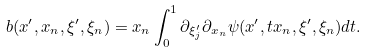Convert formula to latex. <formula><loc_0><loc_0><loc_500><loc_500>b ( x ^ { \prime } , x _ { n } , \xi ^ { \prime } , \xi _ { n } ) = x _ { n } \int _ { 0 } ^ { 1 } \partial _ { \xi ^ { \prime } _ { j } } \partial _ { x _ { n } } \psi ( x ^ { \prime } , t x _ { n } , \xi ^ { \prime } , \xi _ { n } ) d t .</formula> 